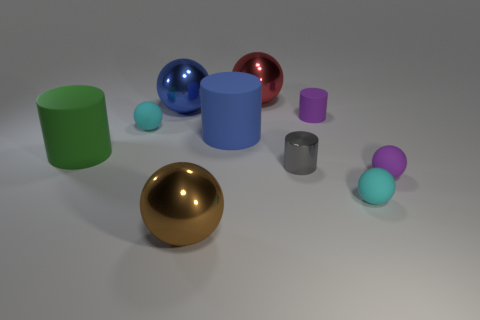There is a blue cylinder that is the same size as the blue ball; what is it made of?
Provide a succinct answer. Rubber. How many small objects are either shiny spheres or cyan cylinders?
Ensure brevity in your answer.  0. Do the gray object and the large blue rubber object have the same shape?
Your response must be concise. Yes. What number of things are both in front of the tiny metal object and to the right of the small gray object?
Make the answer very short. 2. Are there any other things of the same color as the metallic cylinder?
Your response must be concise. No. The big brown thing that is the same material as the large blue ball is what shape?
Ensure brevity in your answer.  Sphere. Do the gray object and the blue rubber object have the same size?
Ensure brevity in your answer.  No. Is the material of the tiny cyan thing to the left of the tiny gray shiny object the same as the green cylinder?
Your answer should be compact. Yes. Is there any other thing that is made of the same material as the blue cylinder?
Give a very brief answer. Yes. There is a small matte ball that is on the right side of the tiny cyan rubber thing right of the large brown object; how many green rubber things are behind it?
Make the answer very short. 1. 